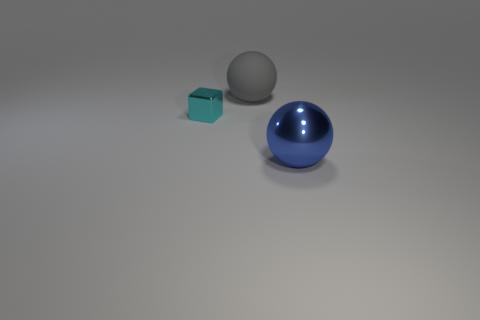Is there anything else that has the same size as the cyan shiny cube?
Ensure brevity in your answer.  No. There is a metal thing on the left side of the ball that is in front of the tiny cyan thing; what color is it?
Keep it short and to the point. Cyan. What number of spheres are small objects or large blue things?
Offer a very short reply. 1. How many objects are both on the left side of the big metallic object and on the right side of the small metal object?
Your response must be concise. 1. There is a shiny object right of the large gray thing; what is its color?
Provide a short and direct response. Blue. What size is the cube that is made of the same material as the blue ball?
Ensure brevity in your answer.  Small. How many big metallic things are right of the tiny cyan block that is behind the shiny ball?
Make the answer very short. 1. There is a small metallic block; what number of big things are in front of it?
Keep it short and to the point. 1. The ball that is behind the metallic object that is behind the ball in front of the gray object is what color?
Provide a short and direct response. Gray. Is the color of the object that is behind the tiny metallic thing the same as the metal object that is on the left side of the big metallic ball?
Make the answer very short. No. 